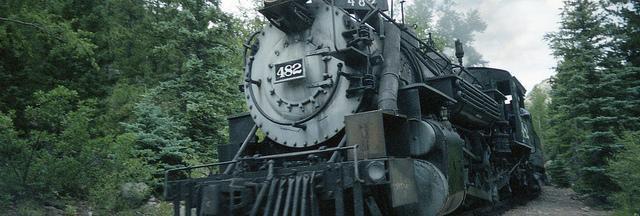How many tracks are there?
Give a very brief answer. 1. How many people carry the surfboard?
Give a very brief answer. 0. 